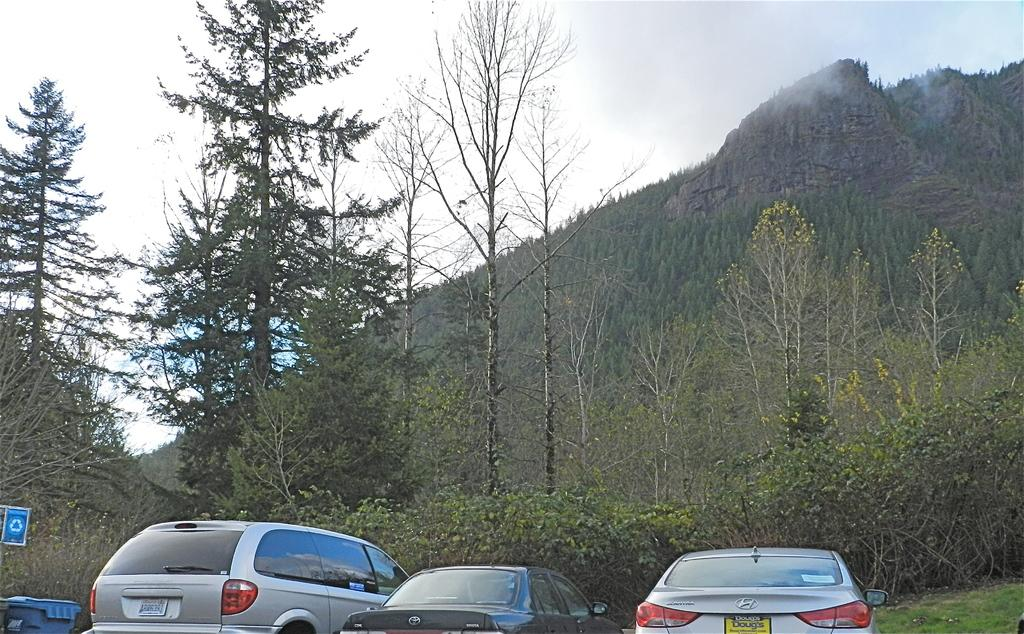What type of vehicles can be seen in the image? There are cars in the image. What other object can be seen in the image besides the cars? There is a sign (vin) in the image. What type of natural vegetation is present in the image? There are trees in the image. What type of geographical feature is present in the image? There is a hill in the image. What is visible in the background of the image? The sky is visible in the background of the image. Where is the prison located in the image? There is no prison present in the image. What type of object is used for carrying food in the image? There is no tray present in the image. 